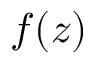<formula> <loc_0><loc_0><loc_500><loc_500>f ( z )</formula> 